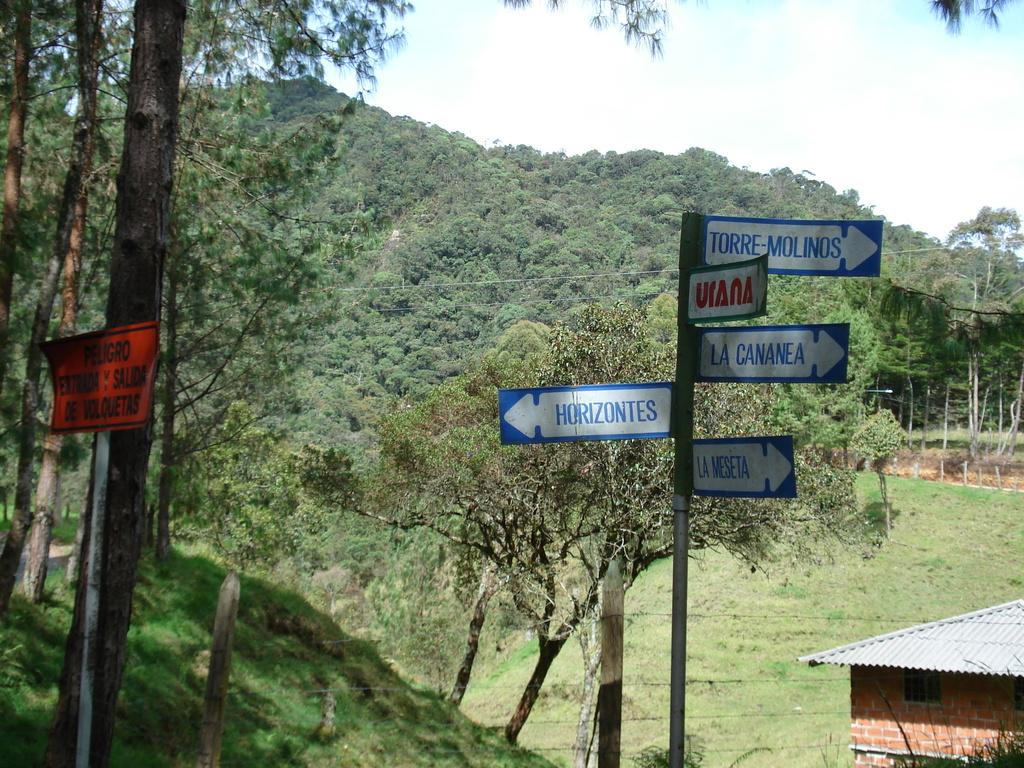What is the main object in the image with direction boards? There is a pole with direction boards in the image. What can be seen in the background of the image? There are trees in the background of the image. What type of vegetation is visible in the image? There is grass visible in the image. What type of structure is present in the image? There is a house in the image. How many snails can be seen crawling on the direction boards in the image? There are no snails visible on the direction boards in the image. 